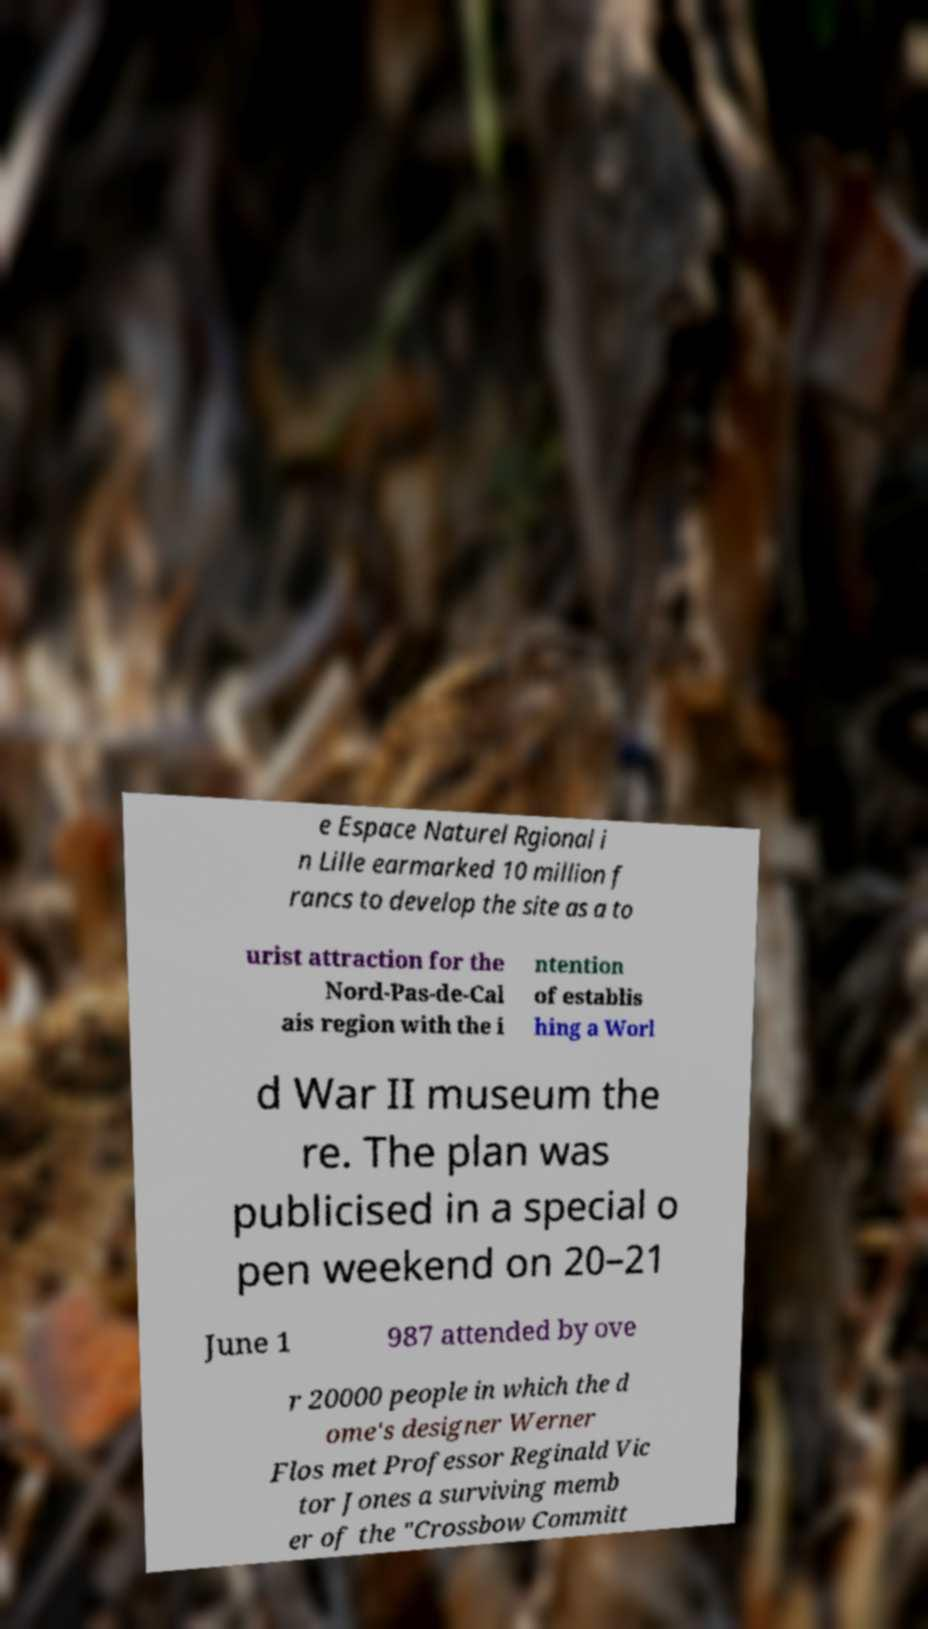Could you assist in decoding the text presented in this image and type it out clearly? e Espace Naturel Rgional i n Lille earmarked 10 million f rancs to develop the site as a to urist attraction for the Nord-Pas-de-Cal ais region with the i ntention of establis hing a Worl d War II museum the re. The plan was publicised in a special o pen weekend on 20–21 June 1 987 attended by ove r 20000 people in which the d ome's designer Werner Flos met Professor Reginald Vic tor Jones a surviving memb er of the "Crossbow Committ 